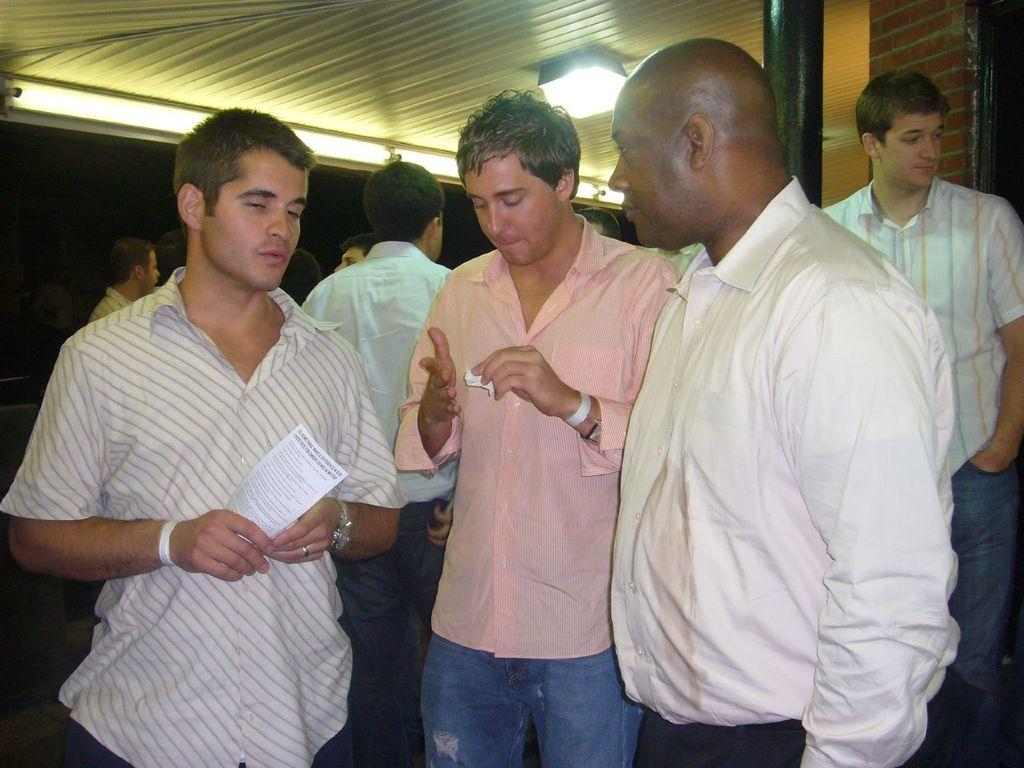How many people are in the image? There are multiple persons in the image. What are the people in the image doing? The persons are standing. Can you describe any specific action or object held by one of the persons? One person is holding a paper. What can be seen at the top of the image? There is light visible at the top of the image. How many pigs are visible in the image? There are no pigs present in the image. What type of chickens can be seen in the image? There are no chickens present in the image. 